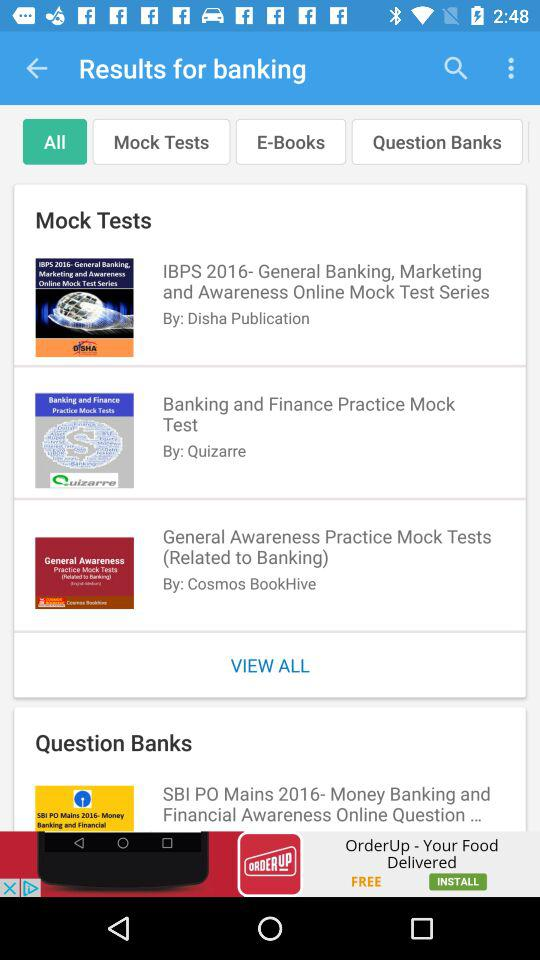How many mock tests are there for banking?
Answer the question using a single word or phrase. 3 